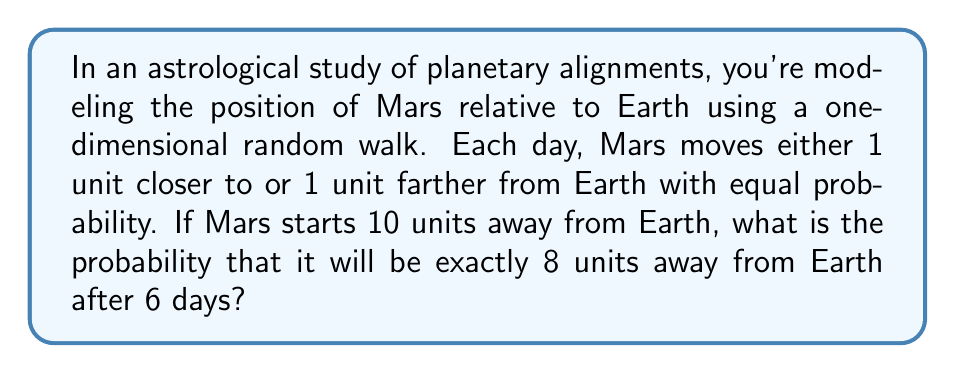Could you help me with this problem? Let's approach this step-by-step:

1) This scenario can be modeled as a binomial random walk. We need to find the probability of being at position 8 after 6 steps, starting from position 10.

2) To reach position 8 from 10 in 6 steps, Mars needs to move 2 units closer to Earth overall. This means we need 4 steps towards Earth and 2 steps away from Earth.

3) The probability of each individual step is 0.5 (equal probability of moving closer or farther).

4) We can use the binomial probability formula:

   $$P(X = k) = \binom{n}{k} p^k (1-p)^{n-k}$$

   where $n$ is the number of trials, $k$ is the number of successes, and $p$ is the probability of success on each trial.

5) In our case:
   $n = 6$ (total steps)
   $k = 4$ (steps towards Earth)
   $p = 0.5$ (probability of moving towards Earth)

6) Plugging into the formula:

   $$P(X = 4) = \binom{6}{4} (0.5)^4 (0.5)^{6-4}$$

7) Simplify:
   $$P(X = 4) = 15 \cdot (0.5)^4 \cdot (0.5)^2 = 15 \cdot (0.5)^6 = \frac{15}{64}$$

Therefore, the probability of Mars being exactly 8 units away from Earth after 6 days is $\frac{15}{64}$.
Answer: $\frac{15}{64}$ 